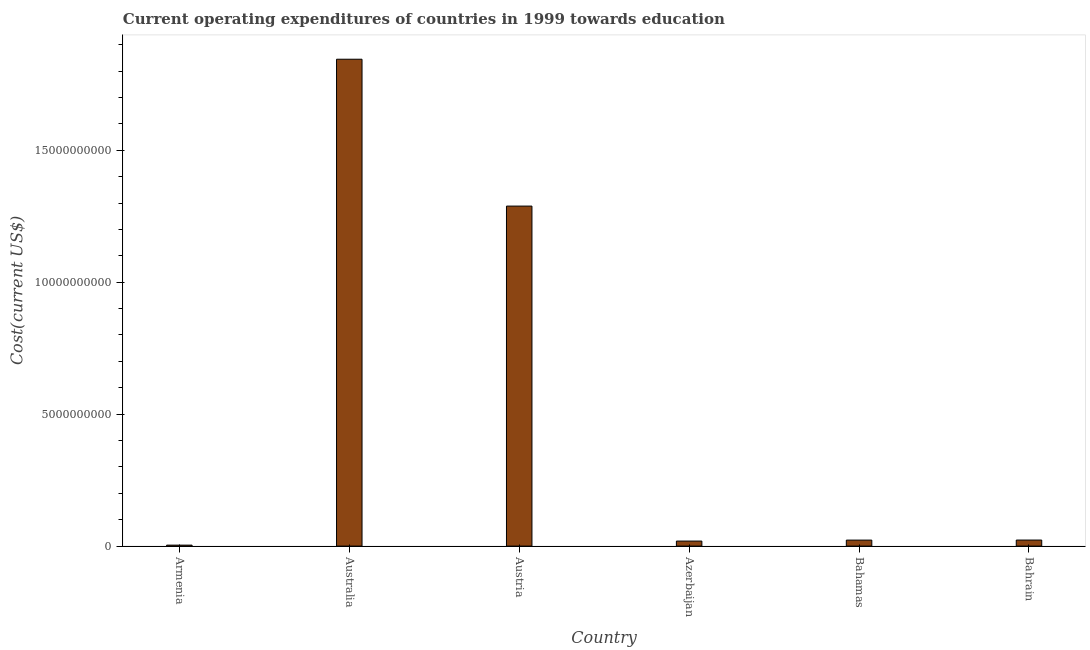Does the graph contain grids?
Give a very brief answer. No. What is the title of the graph?
Your response must be concise. Current operating expenditures of countries in 1999 towards education. What is the label or title of the Y-axis?
Your response must be concise. Cost(current US$). What is the education expenditure in Bahrain?
Your response must be concise. 2.29e+08. Across all countries, what is the maximum education expenditure?
Provide a short and direct response. 1.85e+1. Across all countries, what is the minimum education expenditure?
Give a very brief answer. 3.66e+07. In which country was the education expenditure maximum?
Make the answer very short. Australia. In which country was the education expenditure minimum?
Offer a very short reply. Armenia. What is the sum of the education expenditure?
Offer a very short reply. 3.20e+1. What is the difference between the education expenditure in Austria and Azerbaijan?
Your answer should be very brief. 1.27e+1. What is the average education expenditure per country?
Offer a terse response. 5.34e+09. What is the median education expenditure?
Offer a very short reply. 2.28e+08. What is the ratio of the education expenditure in Austria to that in Bahrain?
Offer a very short reply. 56.19. What is the difference between the highest and the second highest education expenditure?
Your answer should be compact. 5.57e+09. What is the difference between the highest and the lowest education expenditure?
Ensure brevity in your answer.  1.84e+1. Are all the bars in the graph horizontal?
Offer a very short reply. No. Are the values on the major ticks of Y-axis written in scientific E-notation?
Give a very brief answer. No. What is the Cost(current US$) in Armenia?
Provide a short and direct response. 3.66e+07. What is the Cost(current US$) in Australia?
Your answer should be very brief. 1.85e+1. What is the Cost(current US$) in Austria?
Ensure brevity in your answer.  1.29e+1. What is the Cost(current US$) in Azerbaijan?
Provide a succinct answer. 1.91e+08. What is the Cost(current US$) of Bahamas?
Provide a short and direct response. 2.27e+08. What is the Cost(current US$) of Bahrain?
Keep it short and to the point. 2.29e+08. What is the difference between the Cost(current US$) in Armenia and Australia?
Offer a terse response. -1.84e+1. What is the difference between the Cost(current US$) in Armenia and Austria?
Your answer should be very brief. -1.28e+1. What is the difference between the Cost(current US$) in Armenia and Azerbaijan?
Offer a terse response. -1.54e+08. What is the difference between the Cost(current US$) in Armenia and Bahamas?
Offer a very short reply. -1.91e+08. What is the difference between the Cost(current US$) in Armenia and Bahrain?
Your answer should be compact. -1.93e+08. What is the difference between the Cost(current US$) in Australia and Austria?
Provide a succinct answer. 5.57e+09. What is the difference between the Cost(current US$) in Australia and Azerbaijan?
Offer a very short reply. 1.83e+1. What is the difference between the Cost(current US$) in Australia and Bahamas?
Your response must be concise. 1.82e+1. What is the difference between the Cost(current US$) in Australia and Bahrain?
Provide a succinct answer. 1.82e+1. What is the difference between the Cost(current US$) in Austria and Azerbaijan?
Offer a terse response. 1.27e+1. What is the difference between the Cost(current US$) in Austria and Bahamas?
Your response must be concise. 1.27e+1. What is the difference between the Cost(current US$) in Austria and Bahrain?
Offer a terse response. 1.27e+1. What is the difference between the Cost(current US$) in Azerbaijan and Bahamas?
Your answer should be compact. -3.70e+07. What is the difference between the Cost(current US$) in Azerbaijan and Bahrain?
Provide a succinct answer. -3.88e+07. What is the difference between the Cost(current US$) in Bahamas and Bahrain?
Your answer should be very brief. -1.82e+06. What is the ratio of the Cost(current US$) in Armenia to that in Australia?
Your answer should be compact. 0. What is the ratio of the Cost(current US$) in Armenia to that in Austria?
Give a very brief answer. 0. What is the ratio of the Cost(current US$) in Armenia to that in Azerbaijan?
Offer a terse response. 0.19. What is the ratio of the Cost(current US$) in Armenia to that in Bahamas?
Provide a short and direct response. 0.16. What is the ratio of the Cost(current US$) in Armenia to that in Bahrain?
Your response must be concise. 0.16. What is the ratio of the Cost(current US$) in Australia to that in Austria?
Your answer should be very brief. 1.43. What is the ratio of the Cost(current US$) in Australia to that in Azerbaijan?
Your answer should be compact. 96.84. What is the ratio of the Cost(current US$) in Australia to that in Bahamas?
Ensure brevity in your answer.  81.1. What is the ratio of the Cost(current US$) in Australia to that in Bahrain?
Ensure brevity in your answer.  80.46. What is the ratio of the Cost(current US$) in Austria to that in Azerbaijan?
Provide a succinct answer. 67.63. What is the ratio of the Cost(current US$) in Austria to that in Bahamas?
Your response must be concise. 56.64. What is the ratio of the Cost(current US$) in Austria to that in Bahrain?
Your answer should be very brief. 56.19. What is the ratio of the Cost(current US$) in Azerbaijan to that in Bahamas?
Make the answer very short. 0.84. What is the ratio of the Cost(current US$) in Azerbaijan to that in Bahrain?
Offer a very short reply. 0.83. 